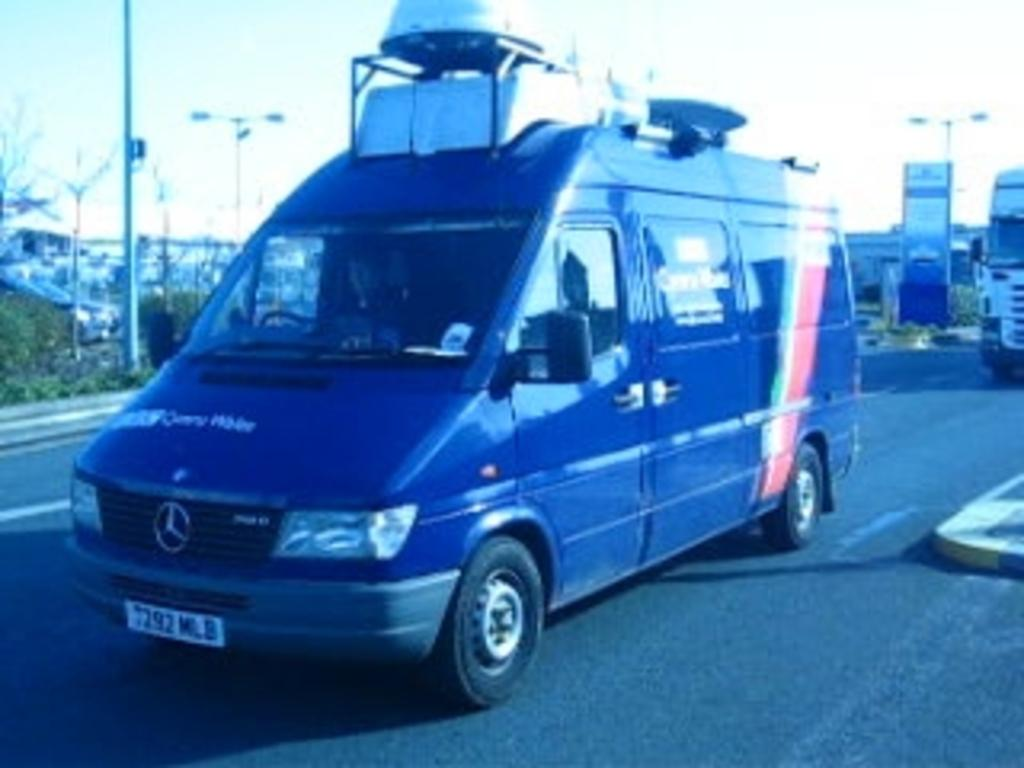<image>
Offer a succinct explanation of the picture presented. A Mercedes van's license plate ends with MLB. 